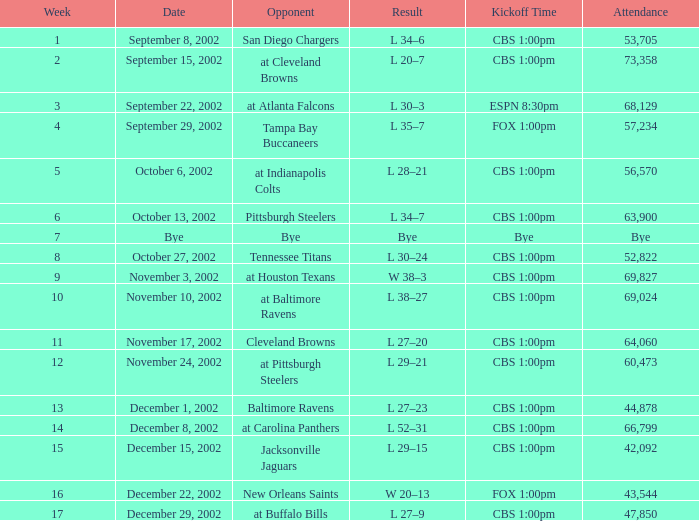What was the attendance count for the game that took place at 1:00pm on cbs, a week prior to week 8, on september 15th, 2002? 73358.0. 